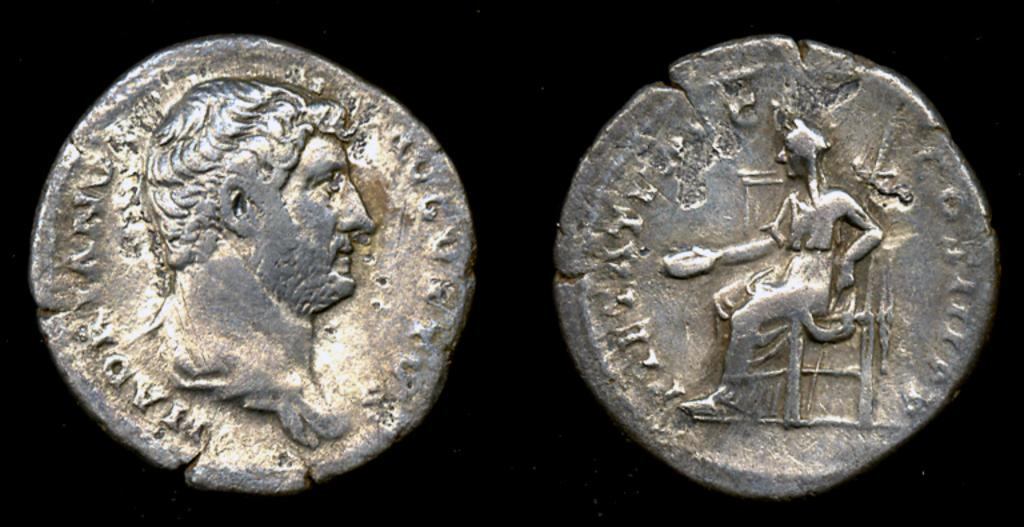What objects are present in the image? There are two coins in the image. What can be seen on the surface of the coins? The coins have sculptures on them. What is the color of the background in the image? The background of the image is dark. What type of cushion is being used to support the yak in the image? There is no cushion or yak present in the image; it only features two coins with sculptures on them. How many leaves of lettuce can be seen in the image? There are no lettuce leaves present in the image. 